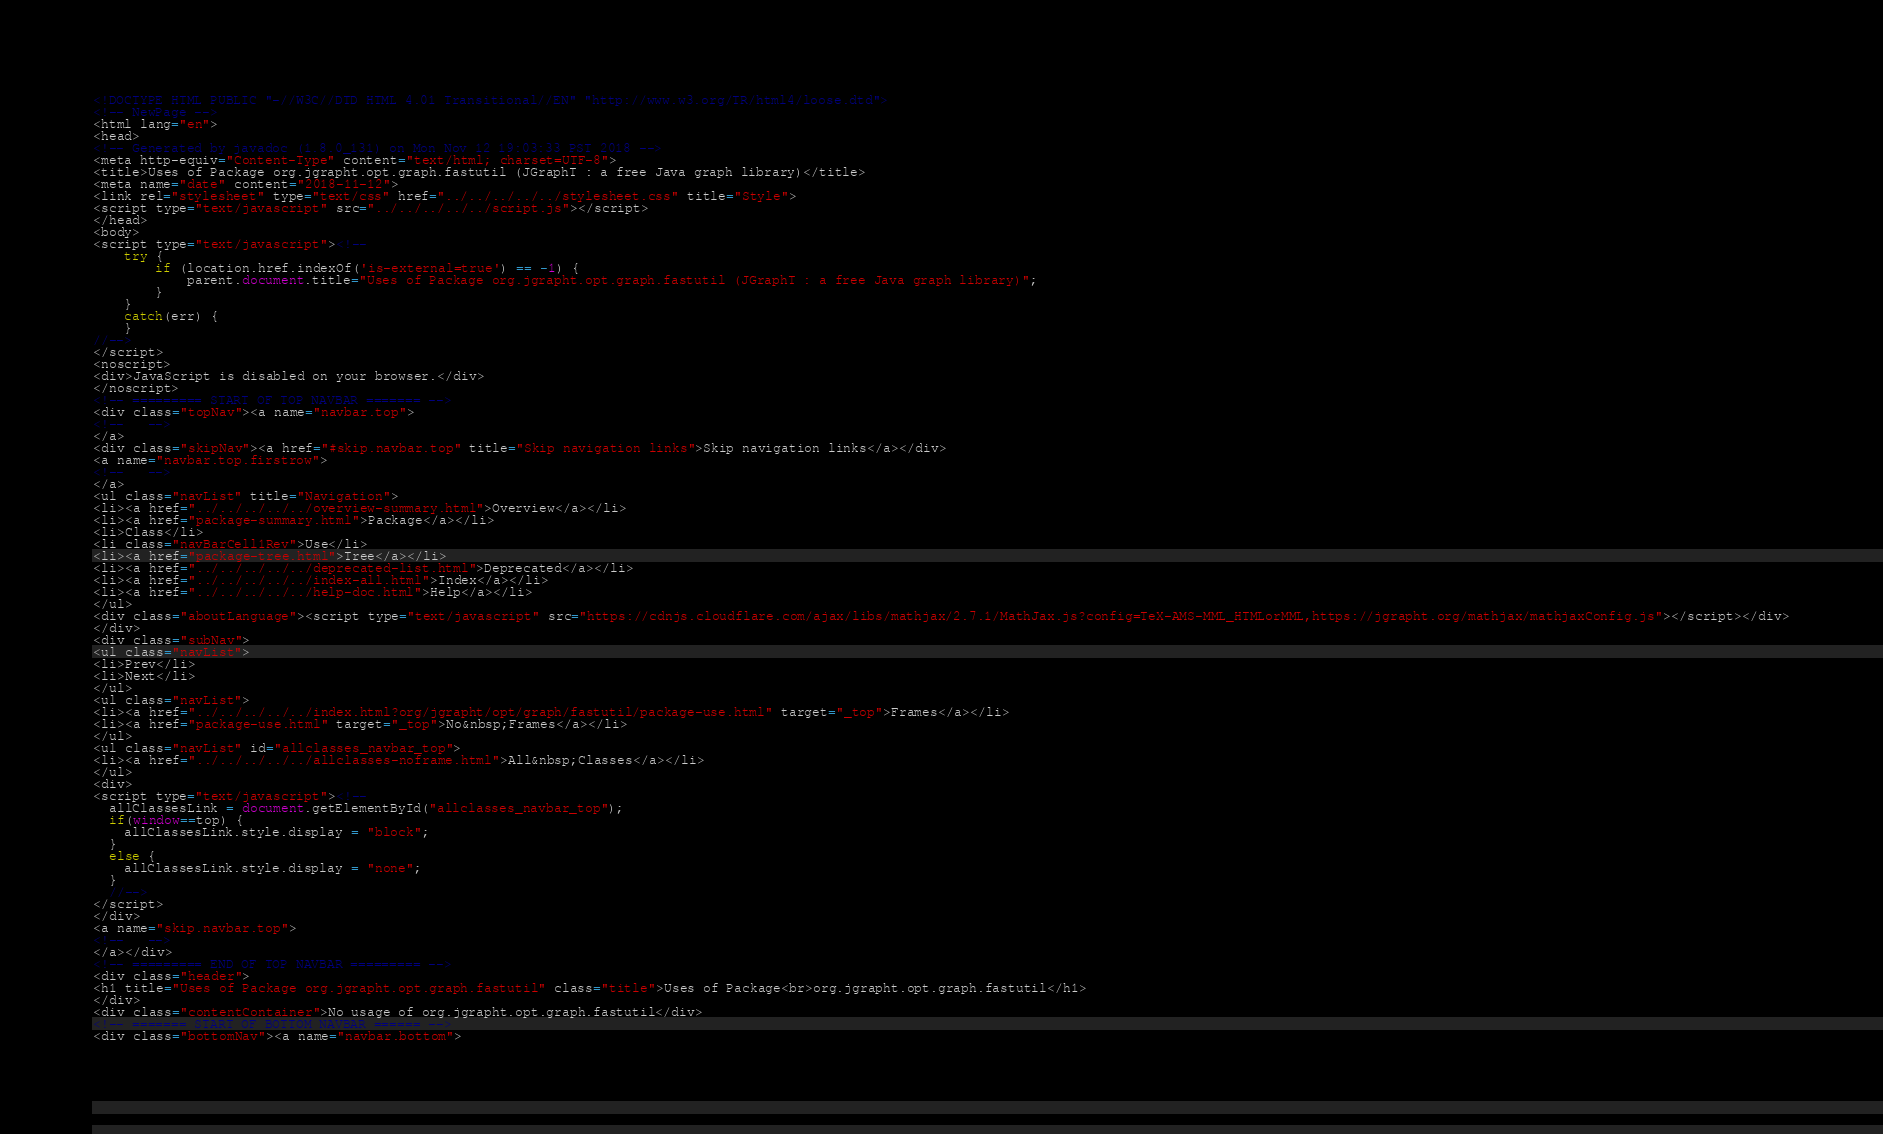<code> <loc_0><loc_0><loc_500><loc_500><_HTML_><!DOCTYPE HTML PUBLIC "-//W3C//DTD HTML 4.01 Transitional//EN" "http://www.w3.org/TR/html4/loose.dtd">
<!-- NewPage -->
<html lang="en">
<head>
<!-- Generated by javadoc (1.8.0_131) on Mon Nov 12 19:03:33 PST 2018 -->
<meta http-equiv="Content-Type" content="text/html; charset=UTF-8">
<title>Uses of Package org.jgrapht.opt.graph.fastutil (JGraphT : a free Java graph library)</title>
<meta name="date" content="2018-11-12">
<link rel="stylesheet" type="text/css" href="../../../../../stylesheet.css" title="Style">
<script type="text/javascript" src="../../../../../script.js"></script>
</head>
<body>
<script type="text/javascript"><!--
    try {
        if (location.href.indexOf('is-external=true') == -1) {
            parent.document.title="Uses of Package org.jgrapht.opt.graph.fastutil (JGraphT : a free Java graph library)";
        }
    }
    catch(err) {
    }
//-->
</script>
<noscript>
<div>JavaScript is disabled on your browser.</div>
</noscript>
<!-- ========= START OF TOP NAVBAR ======= -->
<div class="topNav"><a name="navbar.top">
<!--   -->
</a>
<div class="skipNav"><a href="#skip.navbar.top" title="Skip navigation links">Skip navigation links</a></div>
<a name="navbar.top.firstrow">
<!--   -->
</a>
<ul class="navList" title="Navigation">
<li><a href="../../../../../overview-summary.html">Overview</a></li>
<li><a href="package-summary.html">Package</a></li>
<li>Class</li>
<li class="navBarCell1Rev">Use</li>
<li><a href="package-tree.html">Tree</a></li>
<li><a href="../../../../../deprecated-list.html">Deprecated</a></li>
<li><a href="../../../../../index-all.html">Index</a></li>
<li><a href="../../../../../help-doc.html">Help</a></li>
</ul>
<div class="aboutLanguage"><script type="text/javascript" src="https://cdnjs.cloudflare.com/ajax/libs/mathjax/2.7.1/MathJax.js?config=TeX-AMS-MML_HTMLorMML,https://jgrapht.org/mathjax/mathjaxConfig.js"></script></div>
</div>
<div class="subNav">
<ul class="navList">
<li>Prev</li>
<li>Next</li>
</ul>
<ul class="navList">
<li><a href="../../../../../index.html?org/jgrapht/opt/graph/fastutil/package-use.html" target="_top">Frames</a></li>
<li><a href="package-use.html" target="_top">No&nbsp;Frames</a></li>
</ul>
<ul class="navList" id="allclasses_navbar_top">
<li><a href="../../../../../allclasses-noframe.html">All&nbsp;Classes</a></li>
</ul>
<div>
<script type="text/javascript"><!--
  allClassesLink = document.getElementById("allclasses_navbar_top");
  if(window==top) {
    allClassesLink.style.display = "block";
  }
  else {
    allClassesLink.style.display = "none";
  }
  //-->
</script>
</div>
<a name="skip.navbar.top">
<!--   -->
</a></div>
<!-- ========= END OF TOP NAVBAR ========= -->
<div class="header">
<h1 title="Uses of Package org.jgrapht.opt.graph.fastutil" class="title">Uses of Package<br>org.jgrapht.opt.graph.fastutil</h1>
</div>
<div class="contentContainer">No usage of org.jgrapht.opt.graph.fastutil</div>
<!-- ======= START OF BOTTOM NAVBAR ====== -->
<div class="bottomNav"><a name="navbar.bottom"></code> 